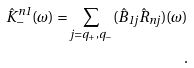<formula> <loc_0><loc_0><loc_500><loc_500>\hat { K } _ { - } ^ { n 1 } ( \omega ) = \sum _ { j = q _ { + } , q _ { - } } ( \hat { B } _ { 1 j } \hat { R } _ { n j } ) ( \omega ) \\ .</formula> 